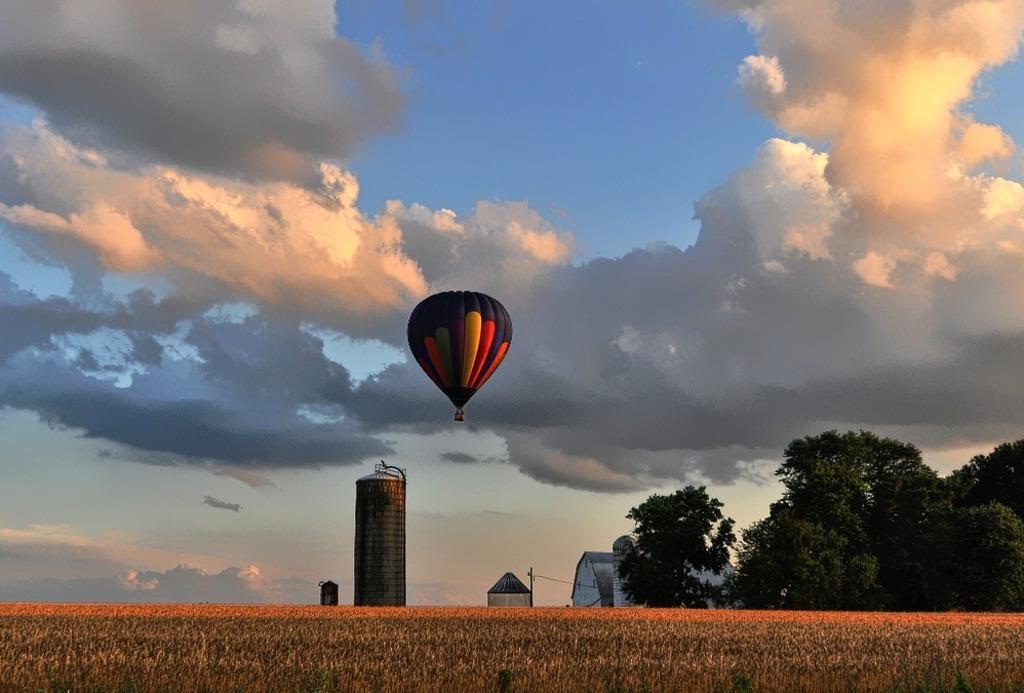Can you describe this image briefly? In this picture we can see grass at the bottom, on the right side there are trees, we can see houses, a metal tank and a hot air balloon in the middle, there is the sky at the top of the picture. 